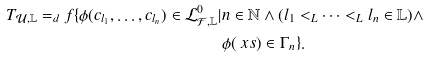<formula> <loc_0><loc_0><loc_500><loc_500>T _ { \mathcal { U } , \mathbb { L } } = _ { d } f \{ \phi ( c _ { l _ { 1 } } , \dots , c _ { l _ { n } } ) \in \mathcal { L } ^ { 0 } _ { \mathcal { F } , \mathbb { L } } | & n \in \mathbb { N } \wedge ( l _ { 1 } < _ { L } \dots < _ { L } l _ { n } \in \mathbb { L } ) \wedge \\ & \phi ( \ x s ) \in \Gamma _ { n } \} .</formula> 